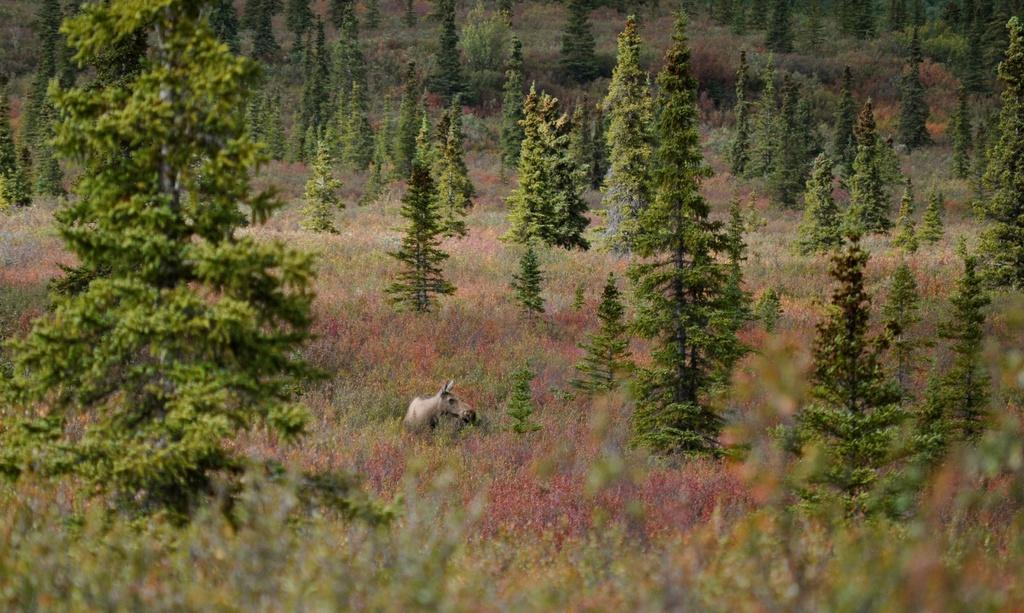What type of animal is on the ground in the image? The specific type of animal cannot be determined from the provided facts. What else can be seen in the image besides the animal? There are plants and trees in the image. Can you describe the plants in the image? The plants in the image cannot be described in detail based on the provided facts. How many trees are visible in the image? The number of trees cannot be determined from the provided facts. What type of clover is growing near the animal in the image? There is no mention of clover in the provided facts, and therefore it cannot be determined if any clover is present in the image. 